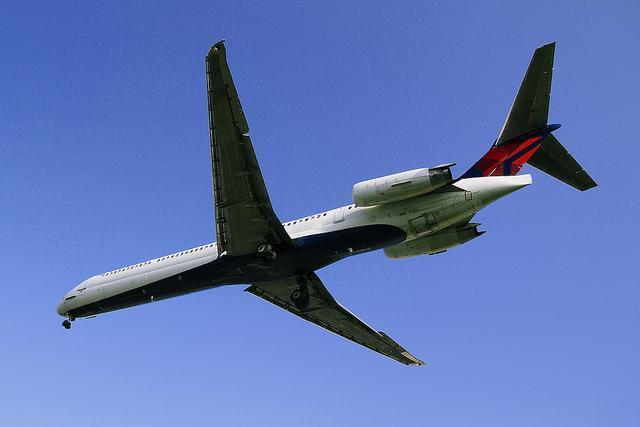How many airplanes can be seen?
Give a very brief answer. 1. 